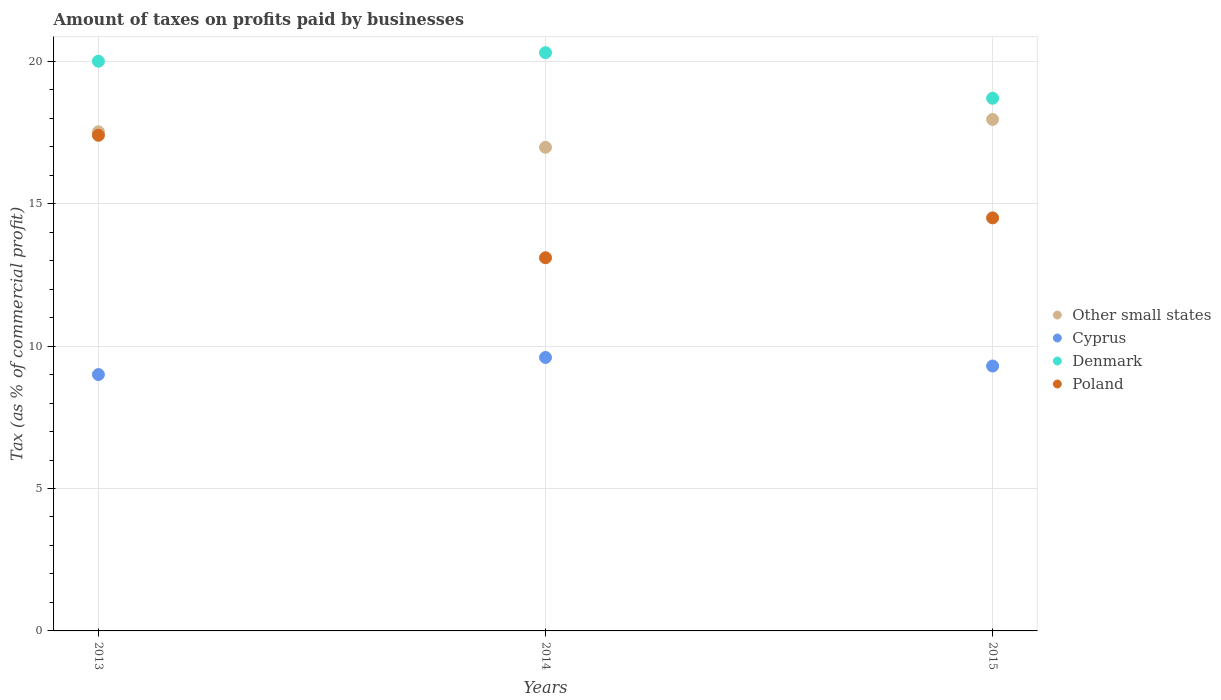Is the number of dotlines equal to the number of legend labels?
Your response must be concise. Yes. What is the percentage of taxes paid by businesses in Poland in 2014?
Your answer should be compact. 13.1. Across all years, what is the maximum percentage of taxes paid by businesses in Denmark?
Offer a terse response. 20.3. Across all years, what is the minimum percentage of taxes paid by businesses in Poland?
Offer a very short reply. 13.1. What is the total percentage of taxes paid by businesses in Other small states in the graph?
Make the answer very short. 52.46. What is the difference between the percentage of taxes paid by businesses in Cyprus in 2013 and that in 2015?
Provide a succinct answer. -0.3. What is the difference between the percentage of taxes paid by businesses in Poland in 2015 and the percentage of taxes paid by businesses in Cyprus in 2014?
Provide a succinct answer. 4.9. What is the average percentage of taxes paid by businesses in Denmark per year?
Your answer should be very brief. 19.67. In the year 2014, what is the difference between the percentage of taxes paid by businesses in Poland and percentage of taxes paid by businesses in Other small states?
Your answer should be very brief. -3.88. What is the ratio of the percentage of taxes paid by businesses in Denmark in 2013 to that in 2015?
Make the answer very short. 1.07. What is the difference between the highest and the second highest percentage of taxes paid by businesses in Denmark?
Offer a terse response. 0.3. What is the difference between the highest and the lowest percentage of taxes paid by businesses in Poland?
Keep it short and to the point. 4.3. In how many years, is the percentage of taxes paid by businesses in Cyprus greater than the average percentage of taxes paid by businesses in Cyprus taken over all years?
Offer a very short reply. 1. Is it the case that in every year, the sum of the percentage of taxes paid by businesses in Poland and percentage of taxes paid by businesses in Denmark  is greater than the percentage of taxes paid by businesses in Cyprus?
Give a very brief answer. Yes. Is the percentage of taxes paid by businesses in Poland strictly greater than the percentage of taxes paid by businesses in Cyprus over the years?
Keep it short and to the point. Yes. Is the percentage of taxes paid by businesses in Cyprus strictly less than the percentage of taxes paid by businesses in Denmark over the years?
Your response must be concise. Yes. How many dotlines are there?
Ensure brevity in your answer.  4. How many years are there in the graph?
Your answer should be very brief. 3. What is the difference between two consecutive major ticks on the Y-axis?
Give a very brief answer. 5. Are the values on the major ticks of Y-axis written in scientific E-notation?
Offer a very short reply. No. Does the graph contain any zero values?
Provide a short and direct response. No. Where does the legend appear in the graph?
Provide a short and direct response. Center right. What is the title of the graph?
Offer a terse response. Amount of taxes on profits paid by businesses. What is the label or title of the X-axis?
Give a very brief answer. Years. What is the label or title of the Y-axis?
Your response must be concise. Tax (as % of commercial profit). What is the Tax (as % of commercial profit) of Other small states in 2013?
Offer a terse response. 17.52. What is the Tax (as % of commercial profit) in Cyprus in 2013?
Your response must be concise. 9. What is the Tax (as % of commercial profit) of Denmark in 2013?
Your response must be concise. 20. What is the Tax (as % of commercial profit) of Poland in 2013?
Your answer should be compact. 17.4. What is the Tax (as % of commercial profit) in Other small states in 2014?
Make the answer very short. 16.98. What is the Tax (as % of commercial profit) of Cyprus in 2014?
Make the answer very short. 9.6. What is the Tax (as % of commercial profit) of Denmark in 2014?
Provide a succinct answer. 20.3. What is the Tax (as % of commercial profit) in Poland in 2014?
Your answer should be compact. 13.1. What is the Tax (as % of commercial profit) of Other small states in 2015?
Provide a short and direct response. 17.96. What is the Tax (as % of commercial profit) in Cyprus in 2015?
Keep it short and to the point. 9.3. Across all years, what is the maximum Tax (as % of commercial profit) of Other small states?
Provide a short and direct response. 17.96. Across all years, what is the maximum Tax (as % of commercial profit) of Cyprus?
Ensure brevity in your answer.  9.6. Across all years, what is the maximum Tax (as % of commercial profit) in Denmark?
Ensure brevity in your answer.  20.3. Across all years, what is the minimum Tax (as % of commercial profit) of Other small states?
Make the answer very short. 16.98. Across all years, what is the minimum Tax (as % of commercial profit) of Denmark?
Your response must be concise. 18.7. What is the total Tax (as % of commercial profit) in Other small states in the graph?
Offer a very short reply. 52.46. What is the total Tax (as % of commercial profit) of Cyprus in the graph?
Your answer should be compact. 27.9. What is the total Tax (as % of commercial profit) of Denmark in the graph?
Keep it short and to the point. 59. What is the difference between the Tax (as % of commercial profit) in Other small states in 2013 and that in 2014?
Your answer should be compact. 0.54. What is the difference between the Tax (as % of commercial profit) of Denmark in 2013 and that in 2014?
Keep it short and to the point. -0.3. What is the difference between the Tax (as % of commercial profit) of Other small states in 2013 and that in 2015?
Make the answer very short. -0.43. What is the difference between the Tax (as % of commercial profit) of Poland in 2013 and that in 2015?
Make the answer very short. 2.9. What is the difference between the Tax (as % of commercial profit) in Other small states in 2014 and that in 2015?
Keep it short and to the point. -0.98. What is the difference between the Tax (as % of commercial profit) of Denmark in 2014 and that in 2015?
Offer a terse response. 1.6. What is the difference between the Tax (as % of commercial profit) of Other small states in 2013 and the Tax (as % of commercial profit) of Cyprus in 2014?
Provide a short and direct response. 7.92. What is the difference between the Tax (as % of commercial profit) of Other small states in 2013 and the Tax (as % of commercial profit) of Denmark in 2014?
Offer a very short reply. -2.78. What is the difference between the Tax (as % of commercial profit) of Other small states in 2013 and the Tax (as % of commercial profit) of Poland in 2014?
Your answer should be very brief. 4.42. What is the difference between the Tax (as % of commercial profit) in Cyprus in 2013 and the Tax (as % of commercial profit) in Poland in 2014?
Give a very brief answer. -4.1. What is the difference between the Tax (as % of commercial profit) in Denmark in 2013 and the Tax (as % of commercial profit) in Poland in 2014?
Your answer should be very brief. 6.9. What is the difference between the Tax (as % of commercial profit) in Other small states in 2013 and the Tax (as % of commercial profit) in Cyprus in 2015?
Offer a very short reply. 8.22. What is the difference between the Tax (as % of commercial profit) in Other small states in 2013 and the Tax (as % of commercial profit) in Denmark in 2015?
Your answer should be compact. -1.18. What is the difference between the Tax (as % of commercial profit) in Other small states in 2013 and the Tax (as % of commercial profit) in Poland in 2015?
Make the answer very short. 3.02. What is the difference between the Tax (as % of commercial profit) of Other small states in 2014 and the Tax (as % of commercial profit) of Cyprus in 2015?
Offer a very short reply. 7.68. What is the difference between the Tax (as % of commercial profit) of Other small states in 2014 and the Tax (as % of commercial profit) of Denmark in 2015?
Your response must be concise. -1.72. What is the difference between the Tax (as % of commercial profit) in Other small states in 2014 and the Tax (as % of commercial profit) in Poland in 2015?
Offer a very short reply. 2.48. What is the difference between the Tax (as % of commercial profit) of Denmark in 2014 and the Tax (as % of commercial profit) of Poland in 2015?
Ensure brevity in your answer.  5.8. What is the average Tax (as % of commercial profit) in Other small states per year?
Keep it short and to the point. 17.49. What is the average Tax (as % of commercial profit) in Denmark per year?
Offer a terse response. 19.67. In the year 2013, what is the difference between the Tax (as % of commercial profit) of Other small states and Tax (as % of commercial profit) of Cyprus?
Provide a succinct answer. 8.52. In the year 2013, what is the difference between the Tax (as % of commercial profit) in Other small states and Tax (as % of commercial profit) in Denmark?
Your response must be concise. -2.48. In the year 2013, what is the difference between the Tax (as % of commercial profit) in Other small states and Tax (as % of commercial profit) in Poland?
Ensure brevity in your answer.  0.12. In the year 2013, what is the difference between the Tax (as % of commercial profit) of Cyprus and Tax (as % of commercial profit) of Poland?
Offer a terse response. -8.4. In the year 2013, what is the difference between the Tax (as % of commercial profit) in Denmark and Tax (as % of commercial profit) in Poland?
Give a very brief answer. 2.6. In the year 2014, what is the difference between the Tax (as % of commercial profit) of Other small states and Tax (as % of commercial profit) of Cyprus?
Provide a short and direct response. 7.38. In the year 2014, what is the difference between the Tax (as % of commercial profit) of Other small states and Tax (as % of commercial profit) of Denmark?
Your answer should be very brief. -3.32. In the year 2014, what is the difference between the Tax (as % of commercial profit) of Other small states and Tax (as % of commercial profit) of Poland?
Give a very brief answer. 3.88. In the year 2014, what is the difference between the Tax (as % of commercial profit) of Cyprus and Tax (as % of commercial profit) of Denmark?
Give a very brief answer. -10.7. In the year 2014, what is the difference between the Tax (as % of commercial profit) of Denmark and Tax (as % of commercial profit) of Poland?
Offer a very short reply. 7.2. In the year 2015, what is the difference between the Tax (as % of commercial profit) in Other small states and Tax (as % of commercial profit) in Cyprus?
Ensure brevity in your answer.  8.66. In the year 2015, what is the difference between the Tax (as % of commercial profit) of Other small states and Tax (as % of commercial profit) of Denmark?
Keep it short and to the point. -0.74. In the year 2015, what is the difference between the Tax (as % of commercial profit) of Other small states and Tax (as % of commercial profit) of Poland?
Ensure brevity in your answer.  3.46. In the year 2015, what is the difference between the Tax (as % of commercial profit) in Cyprus and Tax (as % of commercial profit) in Poland?
Your answer should be compact. -5.2. What is the ratio of the Tax (as % of commercial profit) of Other small states in 2013 to that in 2014?
Your answer should be very brief. 1.03. What is the ratio of the Tax (as % of commercial profit) in Denmark in 2013 to that in 2014?
Give a very brief answer. 0.99. What is the ratio of the Tax (as % of commercial profit) of Poland in 2013 to that in 2014?
Your answer should be compact. 1.33. What is the ratio of the Tax (as % of commercial profit) of Other small states in 2013 to that in 2015?
Provide a short and direct response. 0.98. What is the ratio of the Tax (as % of commercial profit) in Denmark in 2013 to that in 2015?
Keep it short and to the point. 1.07. What is the ratio of the Tax (as % of commercial profit) in Poland in 2013 to that in 2015?
Give a very brief answer. 1.2. What is the ratio of the Tax (as % of commercial profit) in Other small states in 2014 to that in 2015?
Provide a short and direct response. 0.95. What is the ratio of the Tax (as % of commercial profit) in Cyprus in 2014 to that in 2015?
Give a very brief answer. 1.03. What is the ratio of the Tax (as % of commercial profit) of Denmark in 2014 to that in 2015?
Make the answer very short. 1.09. What is the ratio of the Tax (as % of commercial profit) of Poland in 2014 to that in 2015?
Make the answer very short. 0.9. What is the difference between the highest and the second highest Tax (as % of commercial profit) in Other small states?
Give a very brief answer. 0.43. What is the difference between the highest and the second highest Tax (as % of commercial profit) of Cyprus?
Make the answer very short. 0.3. What is the difference between the highest and the second highest Tax (as % of commercial profit) of Denmark?
Keep it short and to the point. 0.3. What is the difference between the highest and the lowest Tax (as % of commercial profit) of Other small states?
Keep it short and to the point. 0.98. What is the difference between the highest and the lowest Tax (as % of commercial profit) in Cyprus?
Make the answer very short. 0.6. What is the difference between the highest and the lowest Tax (as % of commercial profit) in Denmark?
Make the answer very short. 1.6. 